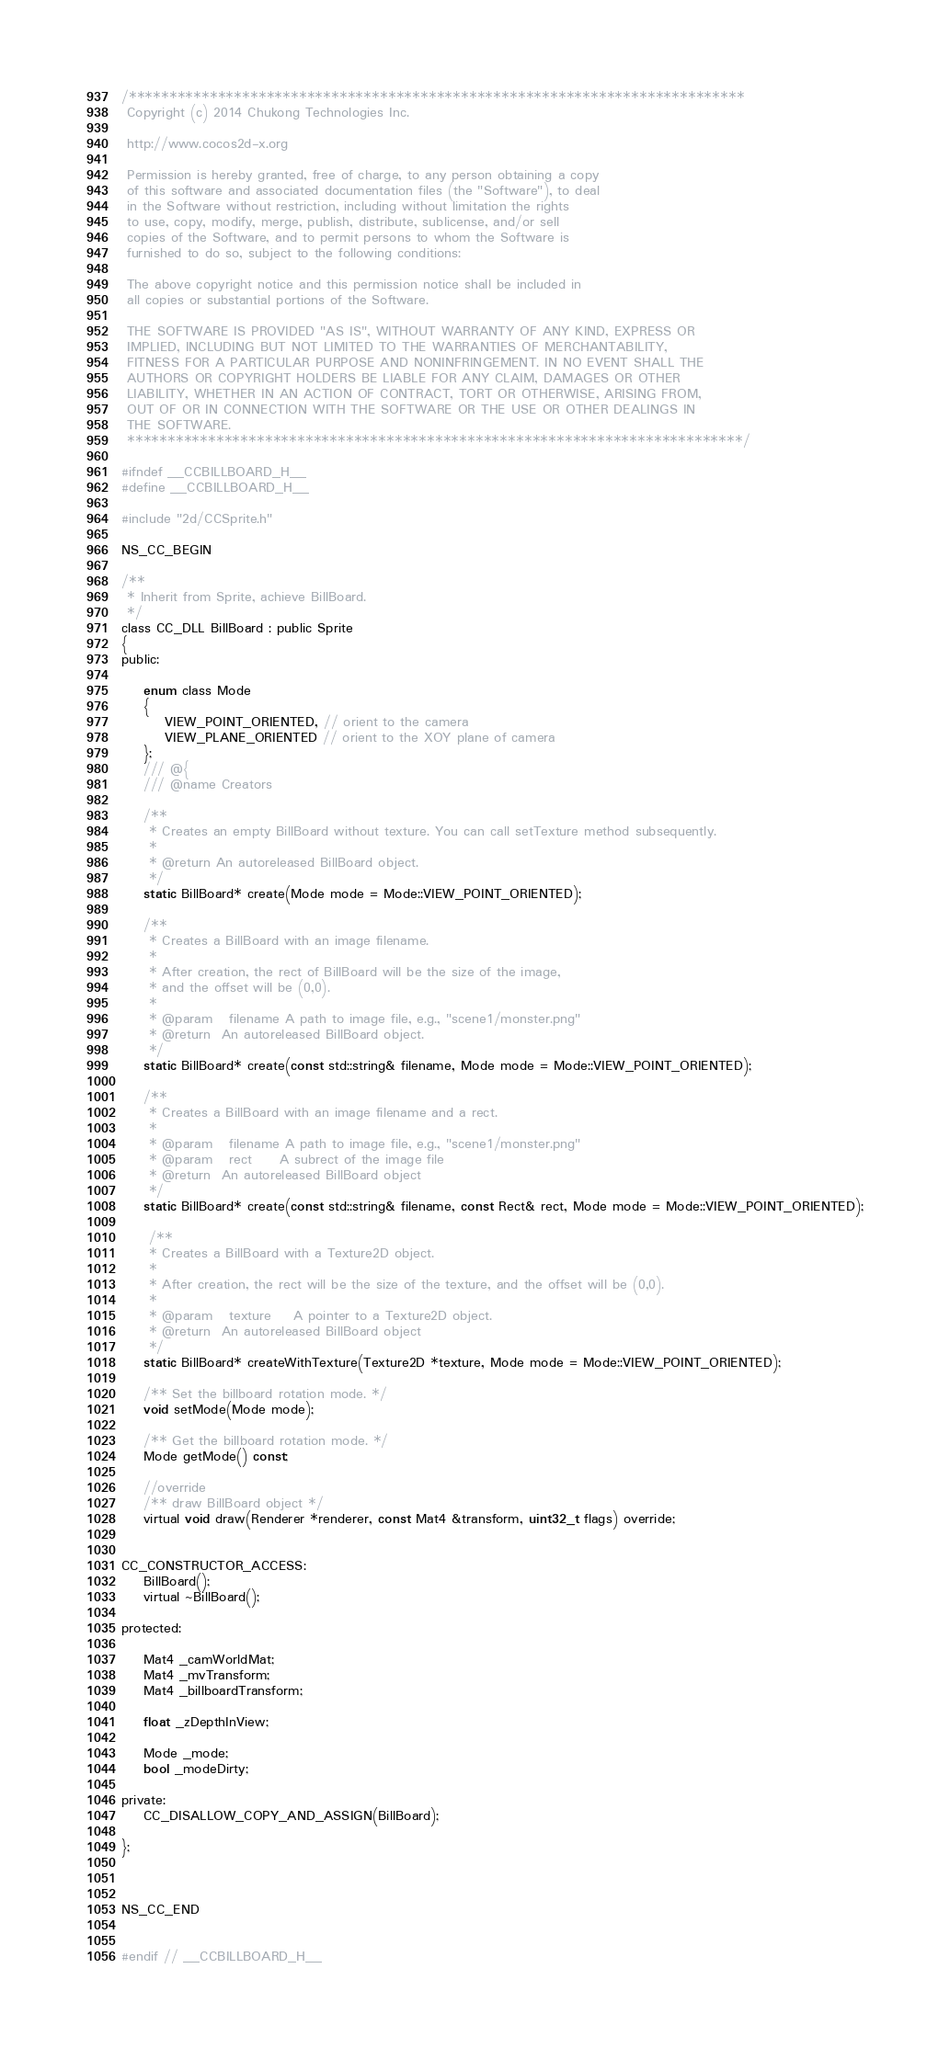Convert code to text. <code><loc_0><loc_0><loc_500><loc_500><_C_>/****************************************************************************
 Copyright (c) 2014 Chukong Technologies Inc.

 http://www.cocos2d-x.org

 Permission is hereby granted, free of charge, to any person obtaining a copy
 of this software and associated documentation files (the "Software"), to deal
 in the Software without restriction, including without limitation the rights
 to use, copy, modify, merge, publish, distribute, sublicense, and/or sell
 copies of the Software, and to permit persons to whom the Software is
 furnished to do so, subject to the following conditions:

 The above copyright notice and this permission notice shall be included in
 all copies or substantial portions of the Software.

 THE SOFTWARE IS PROVIDED "AS IS", WITHOUT WARRANTY OF ANY KIND, EXPRESS OR
 IMPLIED, INCLUDING BUT NOT LIMITED TO THE WARRANTIES OF MERCHANTABILITY,
 FITNESS FOR A PARTICULAR PURPOSE AND NONINFRINGEMENT. IN NO EVENT SHALL THE
 AUTHORS OR COPYRIGHT HOLDERS BE LIABLE FOR ANY CLAIM, DAMAGES OR OTHER
 LIABILITY, WHETHER IN AN ACTION OF CONTRACT, TORT OR OTHERWISE, ARISING FROM,
 OUT OF OR IN CONNECTION WITH THE SOFTWARE OR THE USE OR OTHER DEALINGS IN
 THE SOFTWARE.
 ****************************************************************************/

#ifndef __CCBILLBOARD_H__
#define __CCBILLBOARD_H__

#include "2d/CCSprite.h"

NS_CC_BEGIN

/**
 * Inherit from Sprite, achieve BillBoard.
 */
class CC_DLL BillBoard : public Sprite
{
public:

    enum class Mode
    {
        VIEW_POINT_ORIENTED, // orient to the camera
        VIEW_PLANE_ORIENTED // orient to the XOY plane of camera
    };
    /// @{
    /// @name Creators

    /**
     * Creates an empty BillBoard without texture. You can call setTexture method subsequently.
     *
     * @return An autoreleased BillBoard object.
     */
    static BillBoard* create(Mode mode = Mode::VIEW_POINT_ORIENTED);

    /**
     * Creates a BillBoard with an image filename.
     *
     * After creation, the rect of BillBoard will be the size of the image,
     * and the offset will be (0,0).
     *
     * @param   filename A path to image file, e.g., "scene1/monster.png"
     * @return  An autoreleased BillBoard object.
     */
    static BillBoard* create(const std::string& filename, Mode mode = Mode::VIEW_POINT_ORIENTED);

    /**
     * Creates a BillBoard with an image filename and a rect.
     *
     * @param   filename A path to image file, e.g., "scene1/monster.png"
     * @param   rect     A subrect of the image file
     * @return  An autoreleased BillBoard object
     */
    static BillBoard* create(const std::string& filename, const Rect& rect, Mode mode = Mode::VIEW_POINT_ORIENTED);

     /**
     * Creates a BillBoard with a Texture2D object.
     *
     * After creation, the rect will be the size of the texture, and the offset will be (0,0).
     *
     * @param   texture    A pointer to a Texture2D object.
     * @return  An autoreleased BillBoard object
     */
    static BillBoard* createWithTexture(Texture2D *texture, Mode mode = Mode::VIEW_POINT_ORIENTED);

    /** Set the billboard rotation mode. */
    void setMode(Mode mode);

    /** Get the billboard rotation mode. */
    Mode getMode() const;

    //override
    /** draw BillBoard object */
    virtual void draw(Renderer *renderer, const Mat4 &transform, uint32_t flags) override;


CC_CONSTRUCTOR_ACCESS:
    BillBoard();
    virtual ~BillBoard();

protected:

    Mat4 _camWorldMat;
    Mat4 _mvTransform;
    Mat4 _billboardTransform;
    
    float _zDepthInView;

    Mode _mode;
    bool _modeDirty;

private:
    CC_DISALLOW_COPY_AND_ASSIGN(BillBoard);

};



NS_CC_END


#endif // __CCBILLBOARD_H__
</code> 